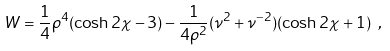<formula> <loc_0><loc_0><loc_500><loc_500>W = \frac { 1 } { 4 } \rho ^ { 4 } ( \cosh 2 \chi - 3 ) - \frac { 1 } { 4 \rho ^ { 2 } } ( \nu ^ { 2 } + \nu ^ { - 2 } ) ( \cosh 2 \chi + 1 ) \ ,</formula> 